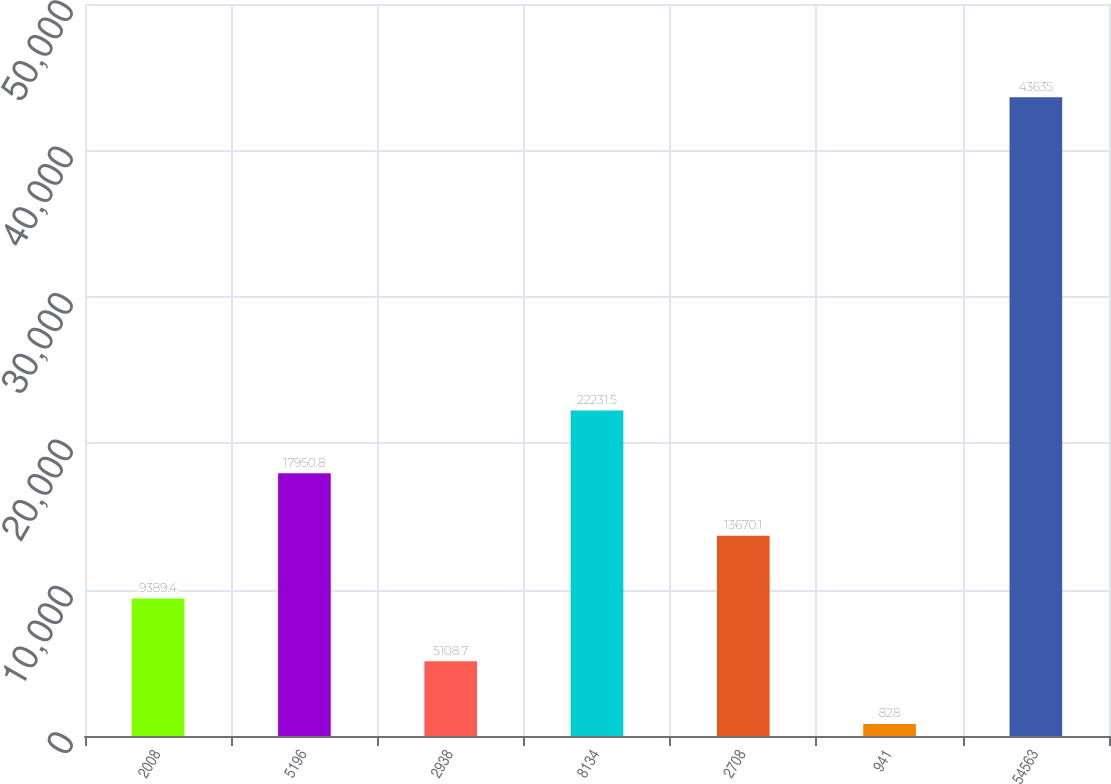Convert chart to OTSL. <chart><loc_0><loc_0><loc_500><loc_500><bar_chart><fcel>2008<fcel>5196<fcel>2938<fcel>8134<fcel>2708<fcel>941<fcel>54563<nl><fcel>9389.4<fcel>17950.8<fcel>5108.7<fcel>22231.5<fcel>13670.1<fcel>828<fcel>43635<nl></chart> 